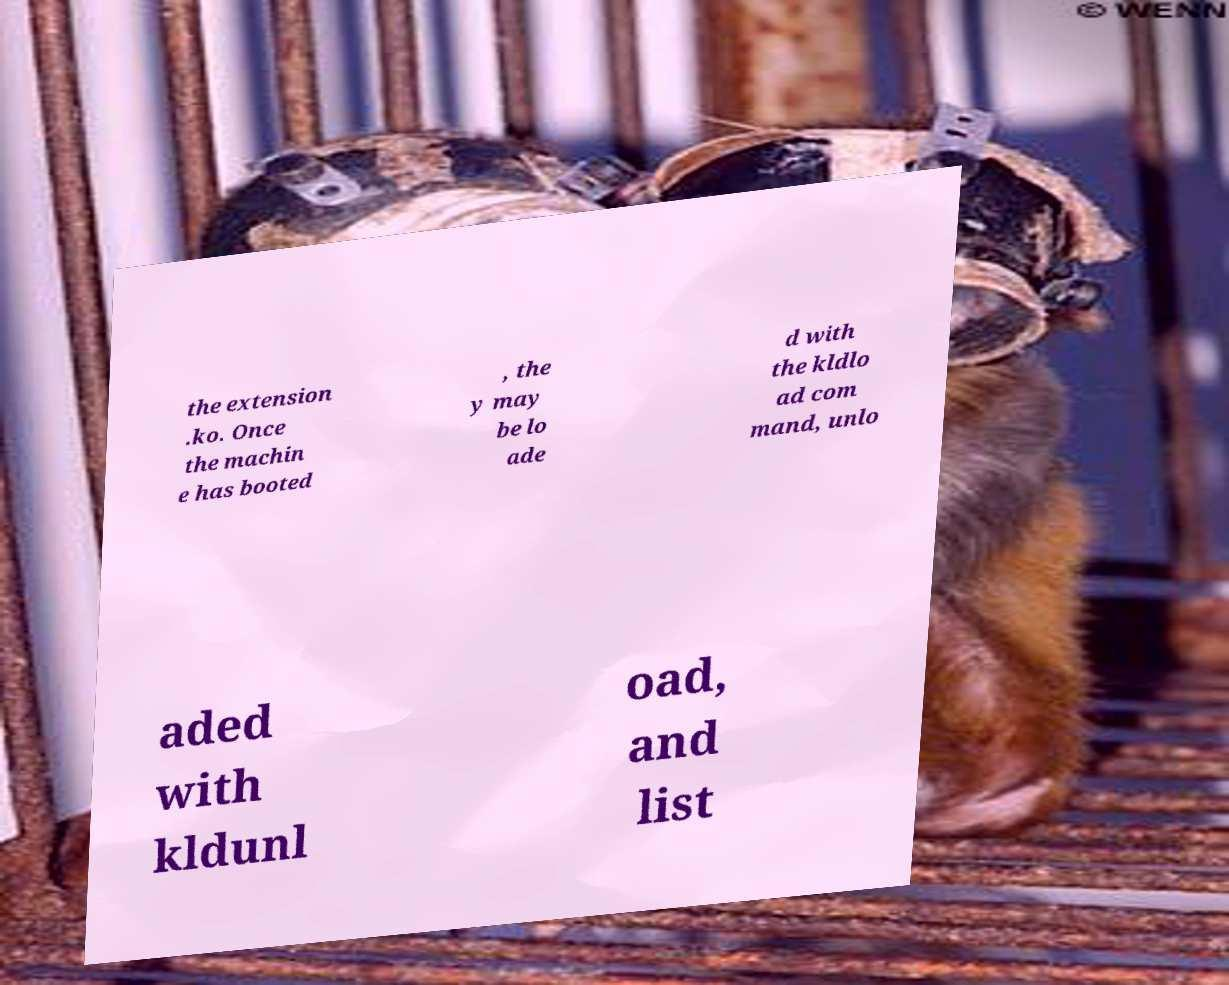Can you accurately transcribe the text from the provided image for me? the extension .ko. Once the machin e has booted , the y may be lo ade d with the kldlo ad com mand, unlo aded with kldunl oad, and list 